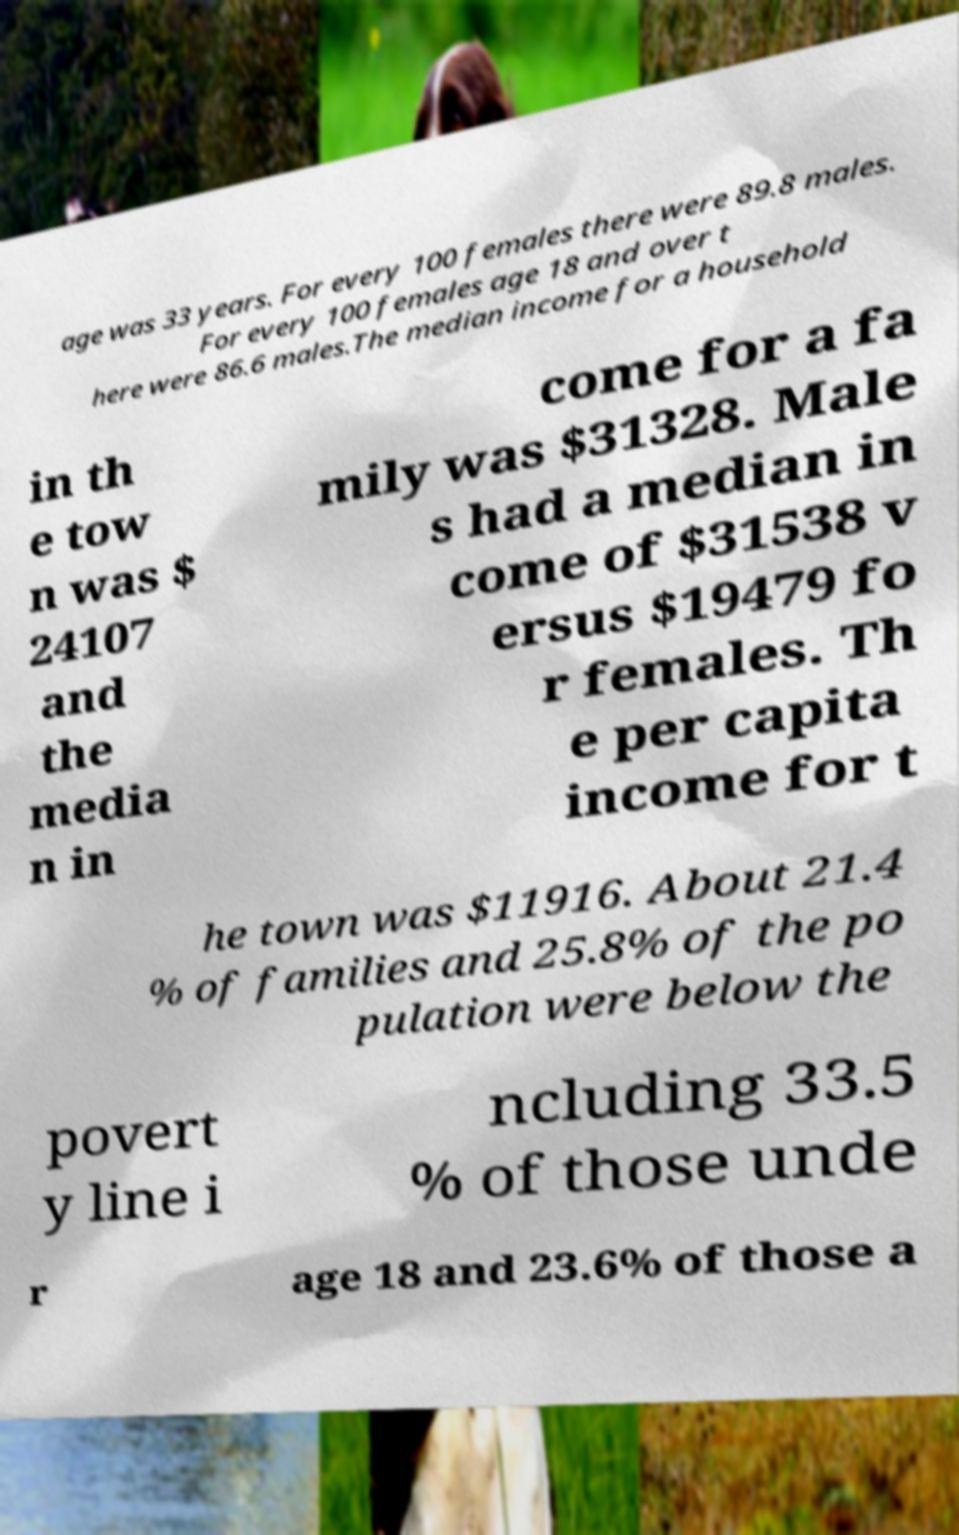Can you read and provide the text displayed in the image?This photo seems to have some interesting text. Can you extract and type it out for me? age was 33 years. For every 100 females there were 89.8 males. For every 100 females age 18 and over t here were 86.6 males.The median income for a household in th e tow n was $ 24107 and the media n in come for a fa mily was $31328. Male s had a median in come of $31538 v ersus $19479 fo r females. Th e per capita income for t he town was $11916. About 21.4 % of families and 25.8% of the po pulation were below the povert y line i ncluding 33.5 % of those unde r age 18 and 23.6% of those a 